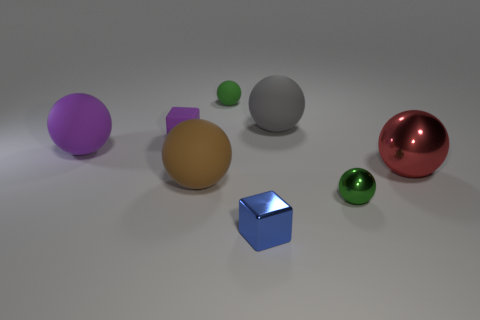Subtract all brown balls. How many balls are left? 5 Subtract all red metallic balls. How many balls are left? 5 Subtract 3 balls. How many balls are left? 3 Subtract all gray balls. Subtract all green cubes. How many balls are left? 5 Add 2 big cyan spheres. How many objects exist? 10 Subtract all balls. How many objects are left? 2 Subtract all big metallic cylinders. Subtract all matte balls. How many objects are left? 4 Add 1 small green matte objects. How many small green matte objects are left? 2 Add 4 large metallic things. How many large metallic things exist? 5 Subtract 0 blue cylinders. How many objects are left? 8 